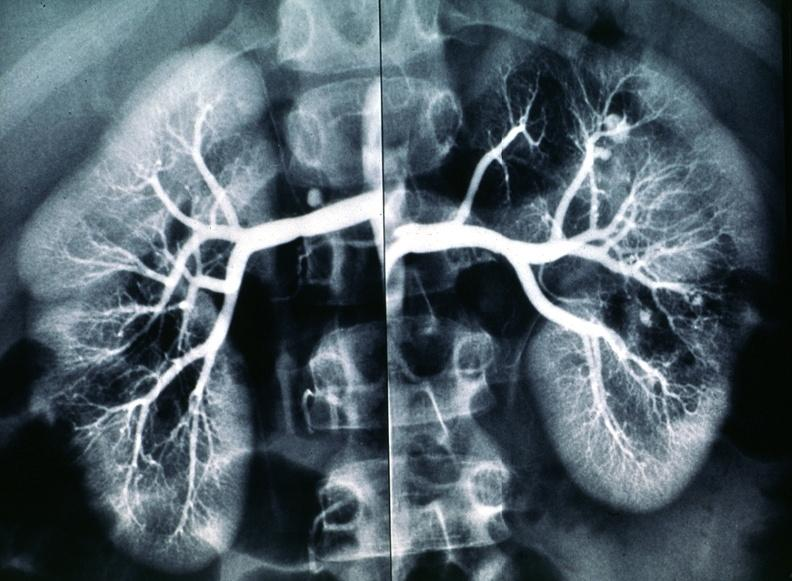where is this?
Answer the question using a single word or phrase. Urinary 